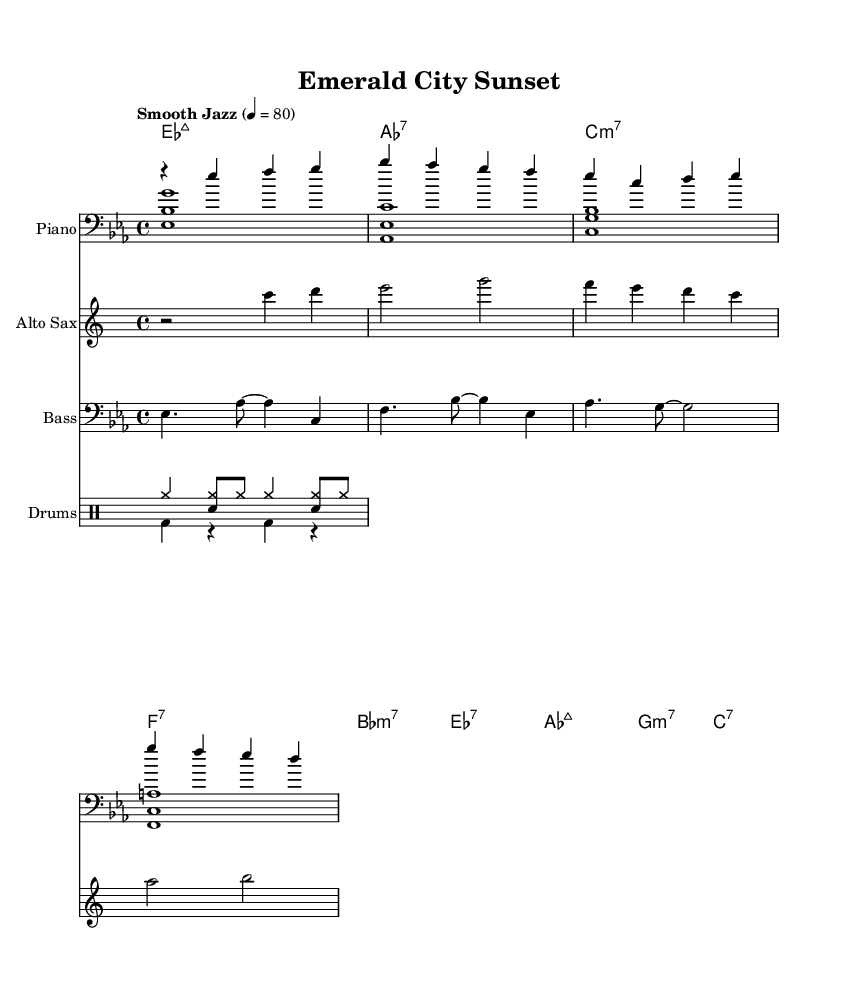What is the key signature of this music? The key signature can be found at the beginning of the score. It shows two flats, which indicates that the piece is in E-flat major.
Answer: E-flat major What is the time signature of this music? The time signature is indicated at the beginning of the score. It shows 4 over 4, meaning there are four beats in each measure and a quarter note gets one beat.
Answer: 4/4 What is the tempo marking of this piece? The tempo marking is indicated at the beginning of the score as "Smooth Jazz," which suggests a laid-back feel. Additionally, the number 80 indicates the beats per minute (BPM).
Answer: Smooth Jazz, 80 How many measures consist of full bars in the piano part? The measures can be counted by identifying the bars in the right hand (pianoRH) and left hand (pianoLH). Counting the visible full measures gives a total of four sets for each section, indicating a total of eight full measures across the entire piece.
Answer: Eight What type of chords are predominantly used in this piece? By examining the chord symbols listed at the top, we see major 7th, dominant 7th, and minor 7th chords, which are characteristic of jazz harmonies. The presence of these types of chords suggests a jazz influence throughout the piece.
Answer: Major 7th, Dominant 7th, Minor 7th Which instrument part plays the melody in this piece? The melody is primarily represented in the saxophone part. Observing that it is in treble clef and has distinct melodic lines indicates its role as the lead instrument.
Answer: Saxophone What is the rhythmic feature in the drumming part? The drumming section features a combination of cymbals and bass drum patterns. The differences in notation between the 'up' (for accents and variations) and 'down' (for the basic pulse) patterns indicate a complex layering typical of jazz drumming.
Answer: Cymbal and bass drum patterns 